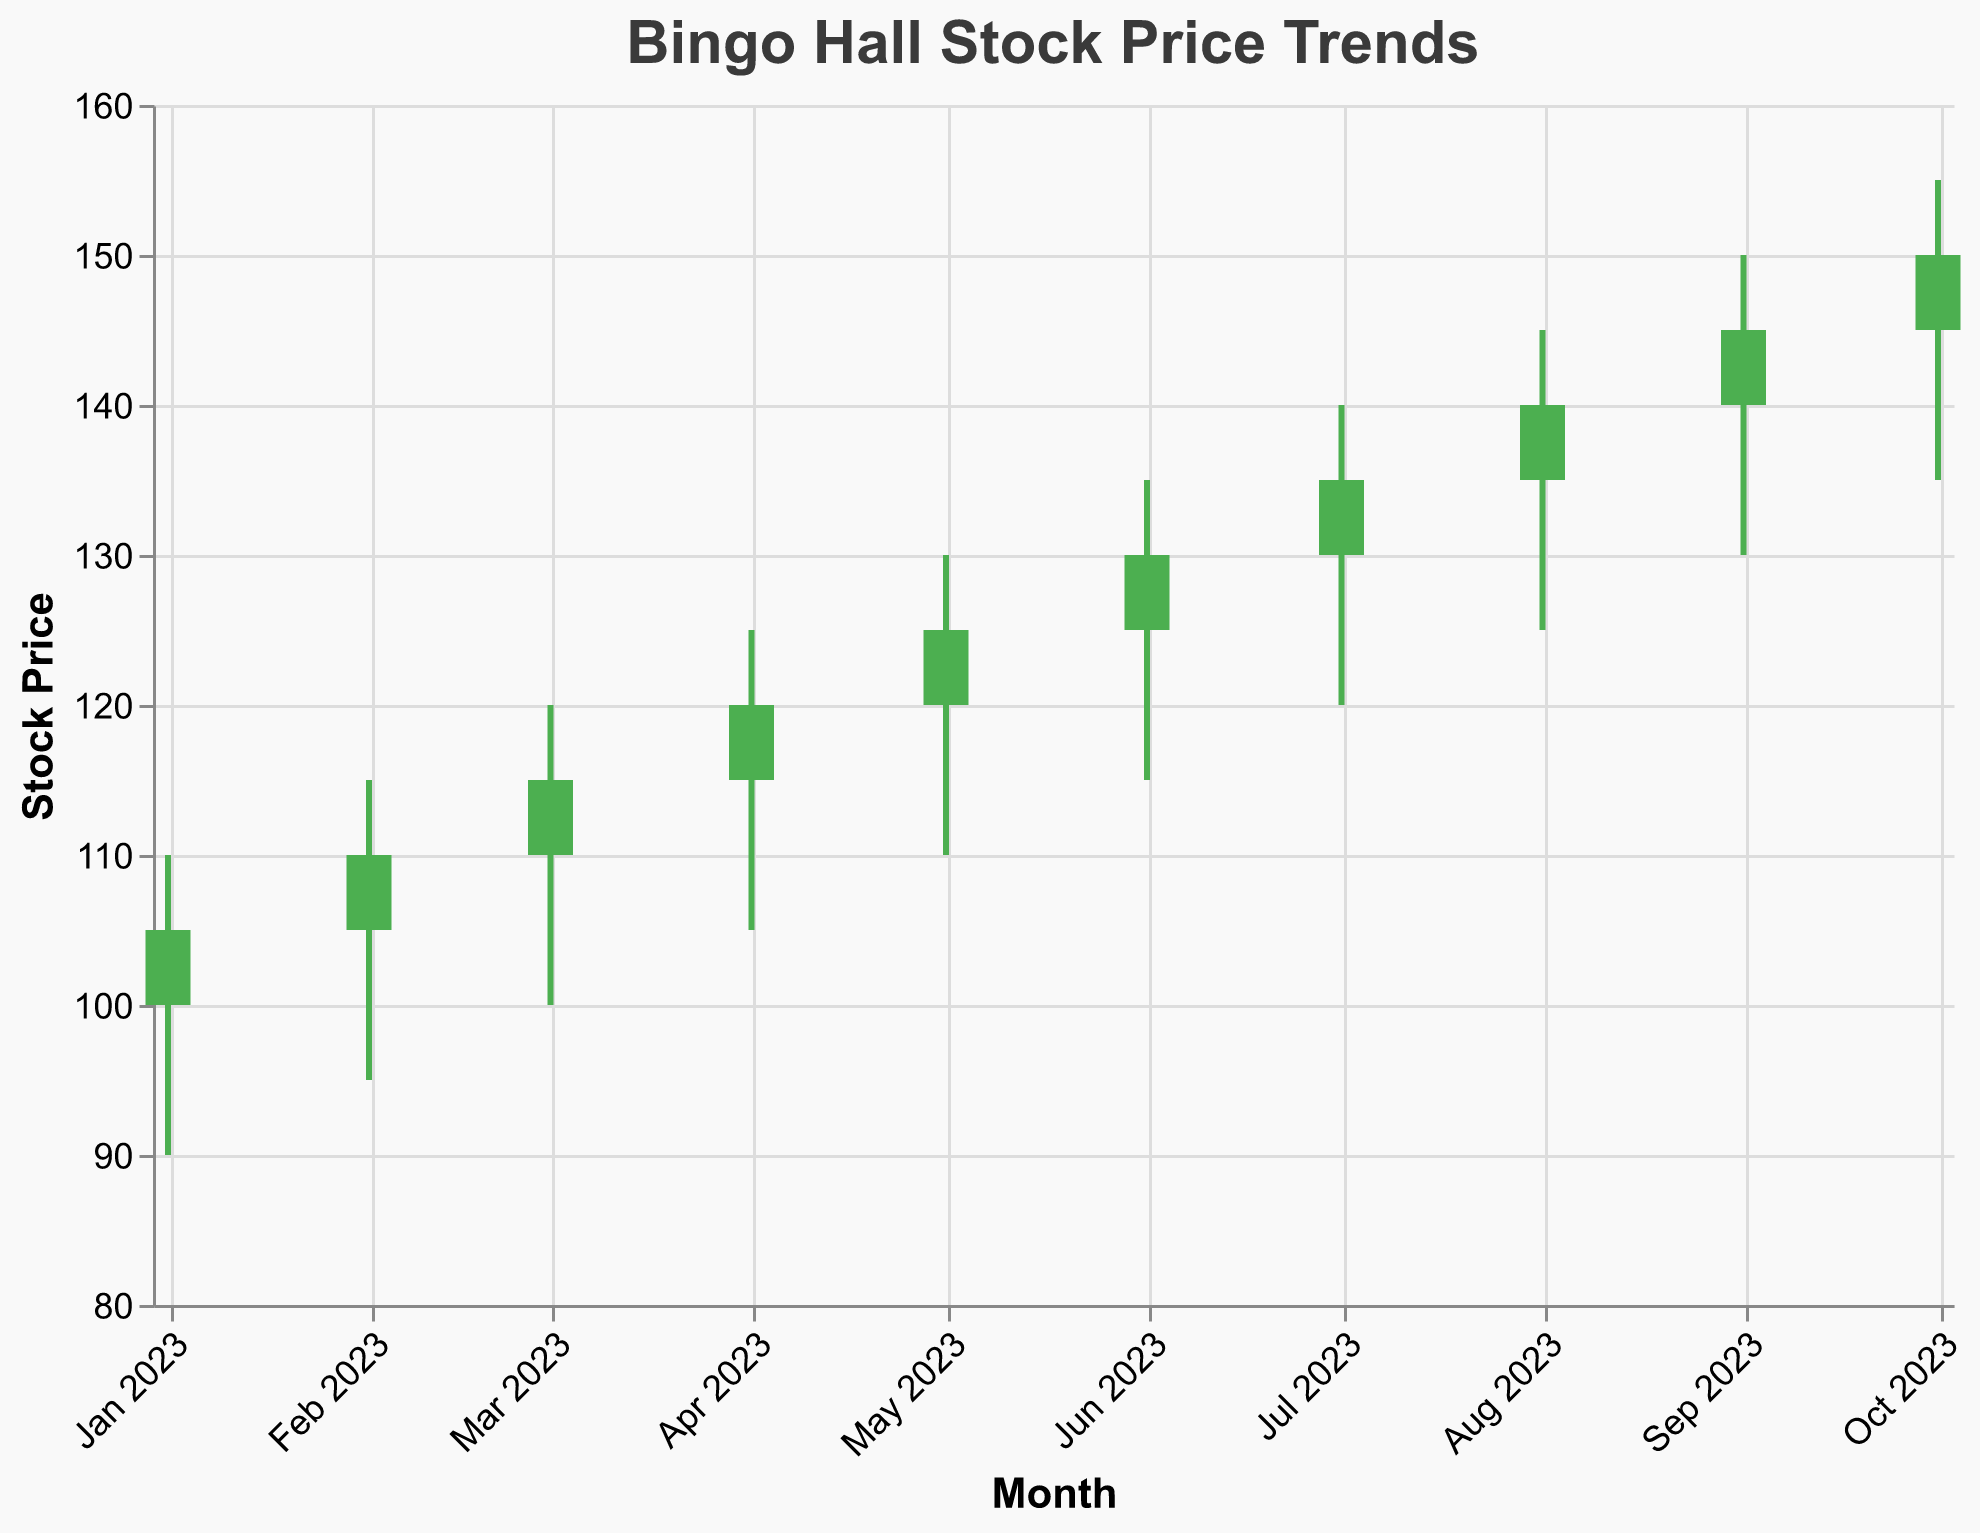What is the title of the chart? The title is typically displayed at the top of the chart. In this case, it is positioned prominently in a larger font and reads "Bingo Hall Stock Price Trends".
Answer: Bingo Hall Stock Price Trends How many data points are shown in the chart? By counting the number of candlestick elements (each representing a month), we can determine there are 10 data points in the figure.
Answer: 10 Which month shows the highest closing stock price? By examining the "Close" value for each candlestick, the highest closing price can be found. October has the highest closing price of 150.
Answer: October What is the color used for candlesticks where the closing price is higher than the opening price? The color's condition specified that these situations are marked with a greenish color, which corresponds to "#4CAF50".
Answer: Green What trend can be observed in the closing stock price from January to October? Observing the closing prices chronologically from January (105) to October (150), a consistent increase can be seen, indicating a rising trend throughout the months.
Answer: Rising trend What is the average closing stock price over the entire period displayed? Sum the closing prices of all the months and divide by the total number of months (10). (105 + 110 + 115 + 120 + 125 + 130 + 135 + 140 + 145 + 150) / 10 = 127.5
Answer: 127.5 Which month shows the largest difference between the high and low prices? For each month, subtract the low price from the high price and find the month with the largest result. The difference for each month are 20 (Jan), 20 (Feb), 20 (Mar), 20 (Apr), 20 (May), 20 (Jun), 20 (Jul), 20 (Aug), 20 (Sep), 20 (Oct). All months have the same largest difference of 20.
Answer: All months (same difference) Between which two consecutive months is the difference in closing stock prices the largest? Calculate the differences between the consecutive months' closing prices: (Feb-Jan) 5, (Mar-Feb) 5, (Apr-Mar) 5, (May-Apr) 5, (Jun-May) 5, (Jul-Jun) 5, (Aug-Jul) 5, (Sep-Aug) 5, (Oct-Sep) 5. The largest difference is the same between each pair of consecutive months, which is 5.
Answer: None, all differences are equal Which month has a drop in stock price compared to its opening price, and what is the amount? By comparing the open and close prices for each month, the month of January (100 vs. 105) shows that the mentioned condition is not met. There is no month shown in the figure where the closing price is lower than the opening price. Hence, there is no drop in stock price shown.
Answer: None 